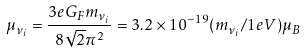Convert formula to latex. <formula><loc_0><loc_0><loc_500><loc_500>\mu _ { \nu _ { i } } = \frac { 3 e G _ { F } m _ { \nu _ { i } } } { 8 \sqrt { 2 } \pi ^ { 2 } } = 3 . 2 \times 1 0 ^ { - 1 9 } ( m _ { \nu _ { i } } / 1 e V ) \mu _ { B }</formula> 